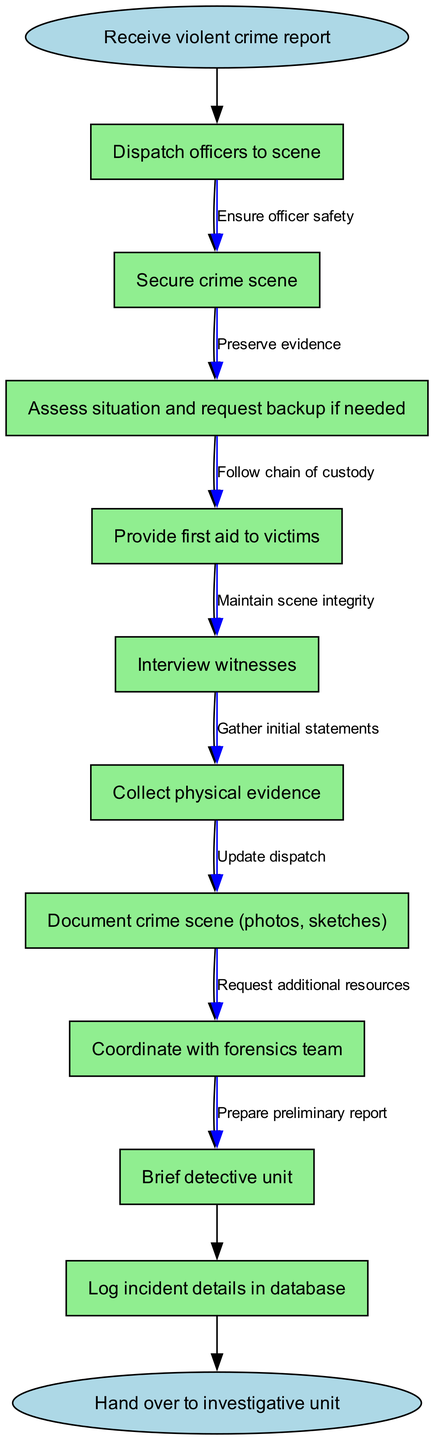What is the starting point of the incident response protocol? The diagram indicates that the starting point is the "Receive violent crime report" node. This is the first action that triggers the entire pathway.
Answer: Receive violent crime report How many nodes are present in the protocol? By counting the nodes described in the diagram, there are 10 nodes, including the start and end nodes.
Answer: 10 What is the last action in the incident response protocol? The last action before the process concludes is "Hand over to investigative unit." This is identified as the end node in the diagram.
Answer: Hand over to investigative unit What must be done after securing the crime scene? The diagram shows a sequence where after securing the crime scene, the next action is to "Assess situation and request backup if needed." This clearly outlines the flow of actions.
Answer: Assess situation and request backup if needed What action involves obtaining statements from individuals present at the scene? "Interview witnesses" is the action labeled in the diagram that specifically requires obtaining statements from people who witnessed the crime.
Answer: Interview witnesses What is needed after providing first aid? Following the action of "Provide first aid to victims," the next step in the protocol is "Interview witnesses." This indicates a clear flow of actions necessary in the therapeutic and investigative process.
Answer: Interview witnesses What is the edge label connecting "Collect physical evidence" and "Document crime scene (photos, sketches)"? The edge label that connects these two nodes is "Preserve evidence." This is crucial in maintaining the integrity of the investigation.
Answer: Preserve evidence Which action is taken to ensure officer safety? The action taken to ensure officer safety is part of the protocol and is labeled as "Ensure officer safety." This is critical for maintaining safety in violent crime scenarios.
Answer: Ensure officer safety What happens after the "Brief detective unit" step? Connectively, after "Brief detective unit", the protocol flows into "Log incident details in database." This indicates the communication and documentation process occurring post-briefing.
Answer: Log incident details in database 